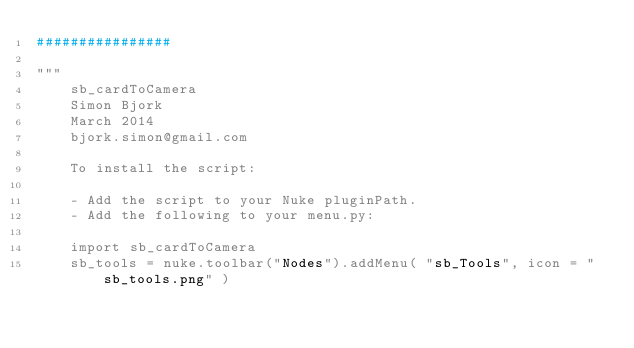<code> <loc_0><loc_0><loc_500><loc_500><_Python_>################

"""
    sb_cardToCamera
    Simon Bjork
    March 2014
    bjork.simon@gmail.com

    To install the script:

    - Add the script to your Nuke pluginPath.
    - Add the following to your menu.py:

    import sb_cardToCamera
    sb_tools = nuke.toolbar("Nodes").addMenu( "sb_Tools", icon = "sb_tools.png" )</code> 